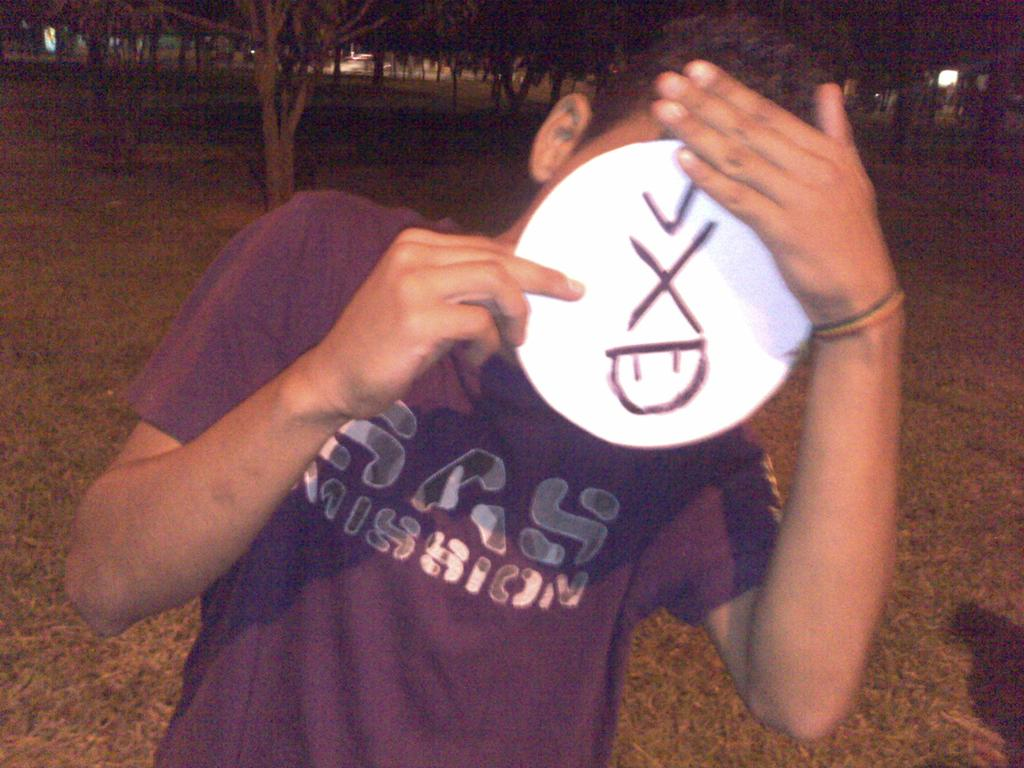<image>
Present a compact description of the photo's key features. a boy wearing a shirt that says sas mission on it 